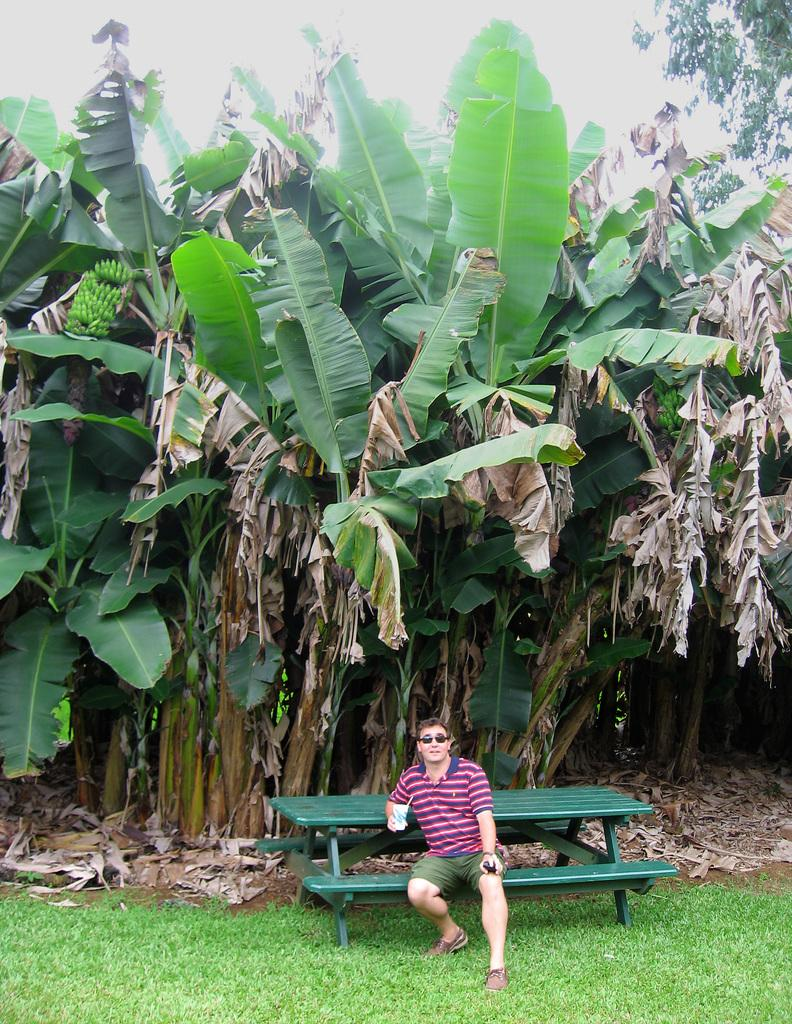What is the man in the image doing? The man is sitting on a bench in the image. What is the man holding in the image? The man is holding a glass in the image. What accessory is the man wearing in the image? The man is wearing glasses (specs) in the image. What can be seen in the background of the image? There are trees visible in the background of the image. What type of day is it in the image? The image does not provide any information about the date or time, so it is not possible to determine the type of day. 